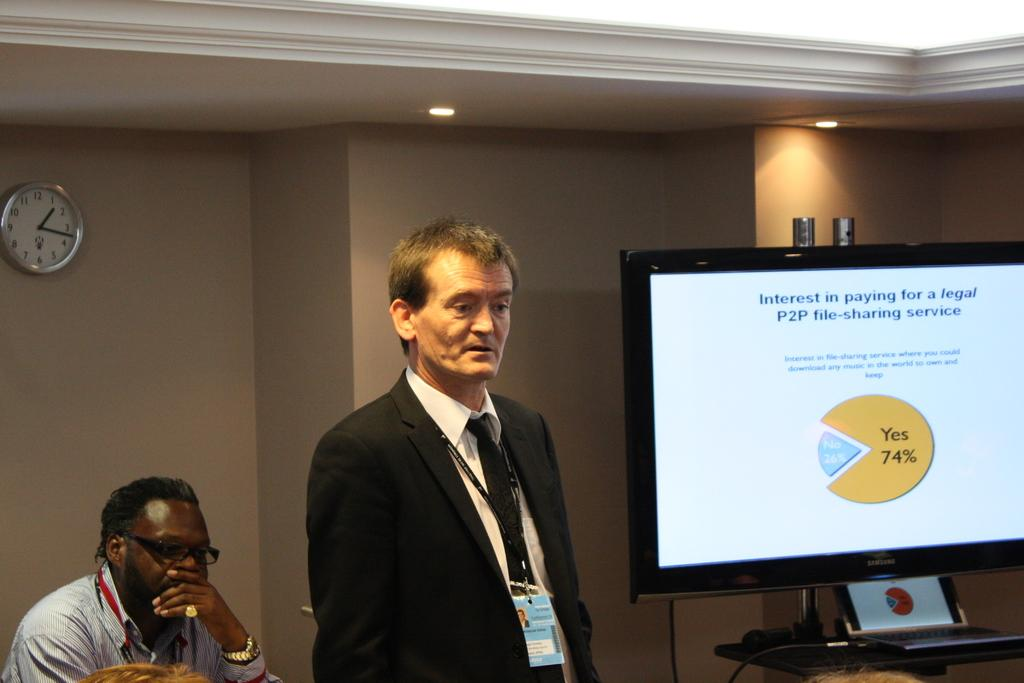Who or what can be seen in the image? There are people in the image. What is on the wall in the image? There is a wall with a clock in the image. What can be seen illuminating the scene in the image? There are lights visible in the image. What electronic devices are present in the image? There is a television on a stand and a laptop on a stand in the image. What type of grip does the committee have on the smell in the image? There is no committee or smell present in the image. 